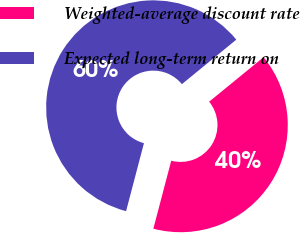Convert chart to OTSL. <chart><loc_0><loc_0><loc_500><loc_500><pie_chart><fcel>Weighted-average discount rate<fcel>Expected long-term return on<nl><fcel>40.0%<fcel>60.0%<nl></chart> 